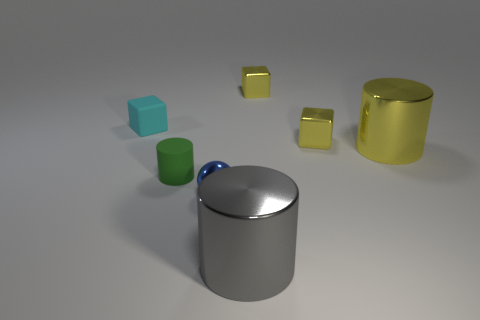Do the big yellow cylinder in front of the small cyan object and the cyan cube have the same material?
Offer a very short reply. No. What number of other objects are there of the same material as the big yellow object?
Your response must be concise. 4. There is a large metal thing behind the big gray shiny thing; is it the same shape as the green thing?
Keep it short and to the point. Yes. Is there any other thing that is the same shape as the green rubber thing?
Offer a terse response. Yes. There is a gray metallic thing that is the same shape as the green rubber object; what size is it?
Make the answer very short. Large. Are there the same number of big gray metal cylinders behind the small cyan object and objects in front of the green matte thing?
Offer a terse response. No. Is the size of the metal object that is in front of the small blue object the same as the object that is left of the tiny green cylinder?
Provide a short and direct response. No. There is a thing that is behind the big gray cylinder and in front of the small matte cylinder; what is its material?
Offer a terse response. Metal. Is the number of objects less than the number of small yellow metal cubes?
Your answer should be very brief. No. There is a metallic cylinder that is in front of the large shiny cylinder behind the large gray object; what is its size?
Your response must be concise. Large. 